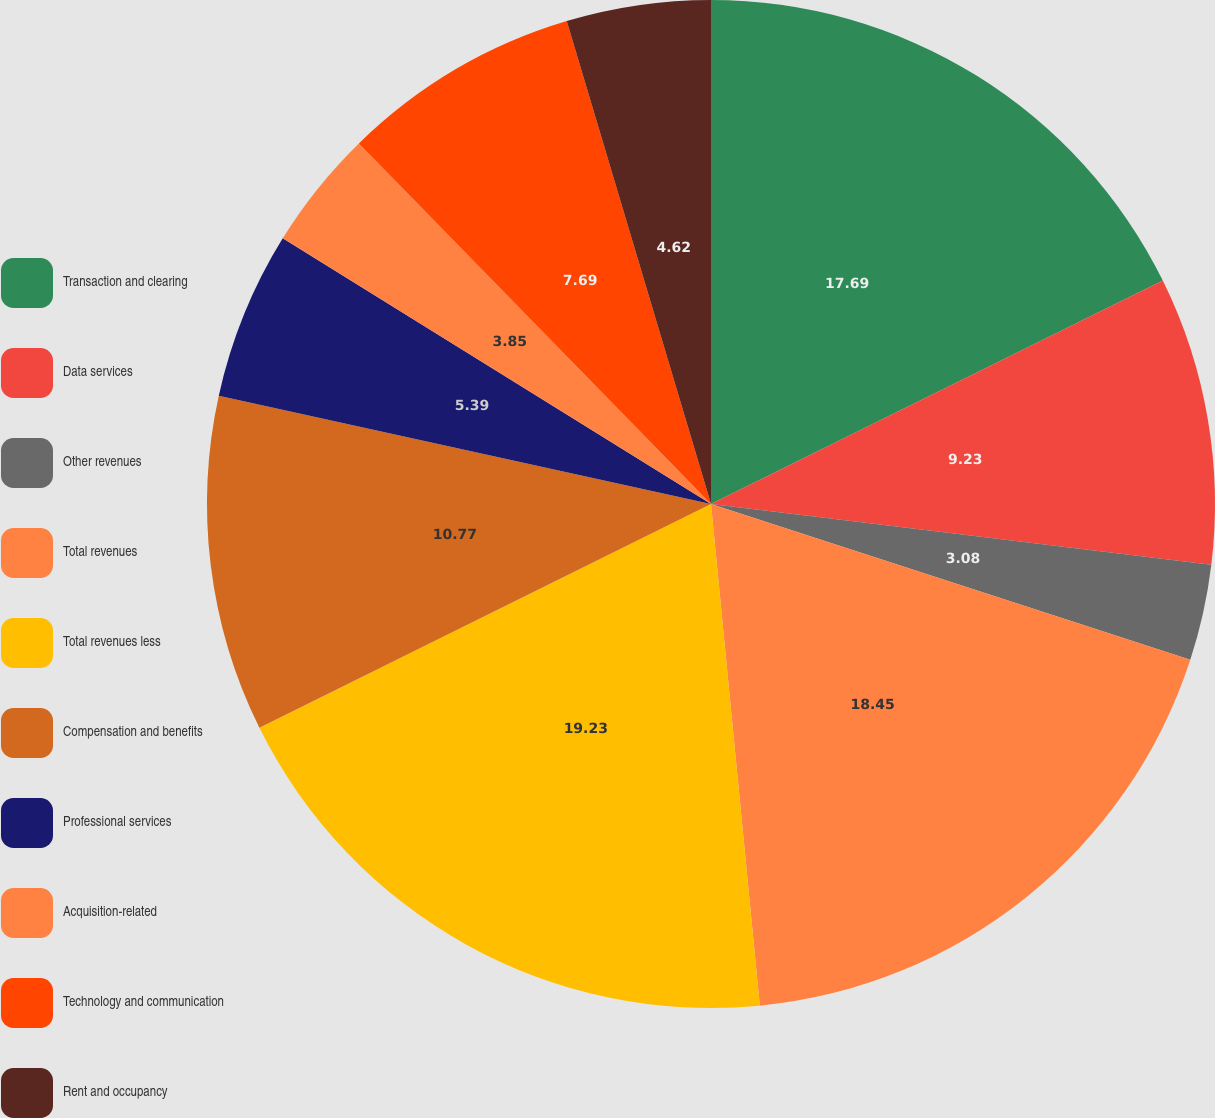<chart> <loc_0><loc_0><loc_500><loc_500><pie_chart><fcel>Transaction and clearing<fcel>Data services<fcel>Other revenues<fcel>Total revenues<fcel>Total revenues less<fcel>Compensation and benefits<fcel>Professional services<fcel>Acquisition-related<fcel>Technology and communication<fcel>Rent and occupancy<nl><fcel>17.69%<fcel>9.23%<fcel>3.08%<fcel>18.45%<fcel>19.22%<fcel>10.77%<fcel>5.39%<fcel>3.85%<fcel>7.69%<fcel>4.62%<nl></chart> 